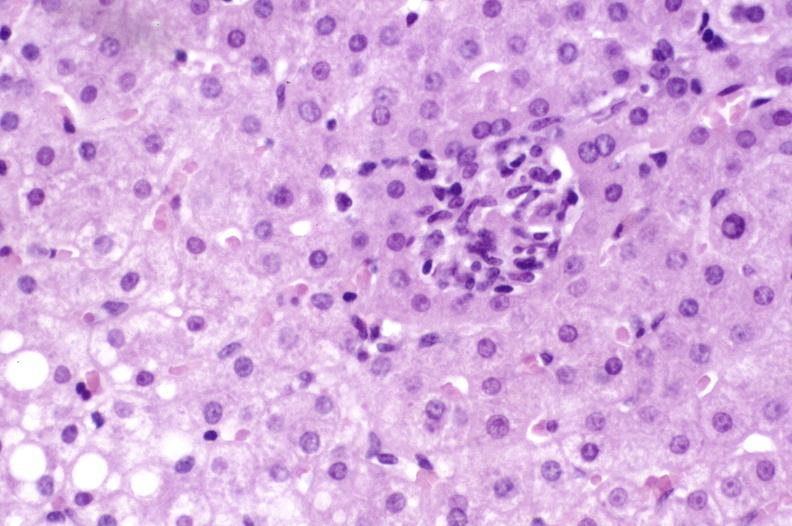s hepatobiliary present?
Answer the question using a single word or phrase. Yes 